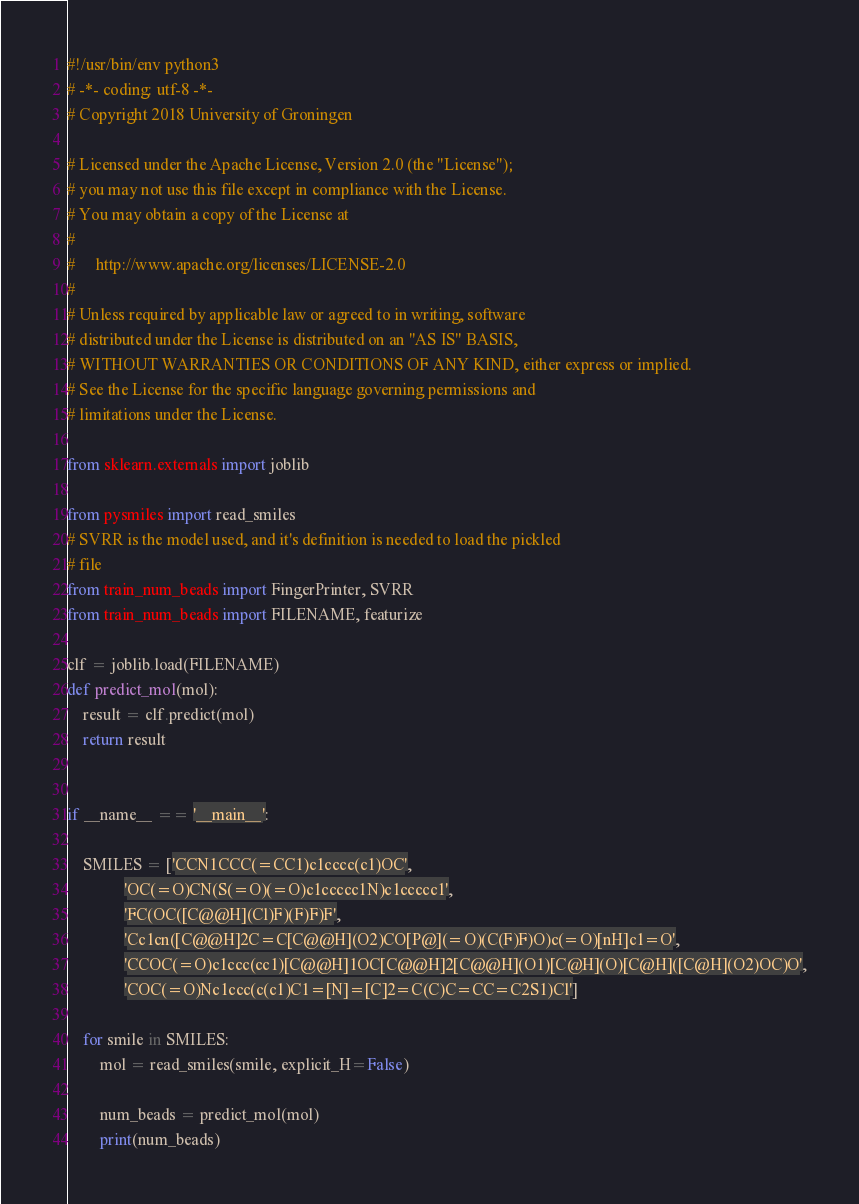Convert code to text. <code><loc_0><loc_0><loc_500><loc_500><_Python_>#!/usr/bin/env python3
# -*- coding: utf-8 -*-
# Copyright 2018 University of Groningen

# Licensed under the Apache License, Version 2.0 (the "License");
# you may not use this file except in compliance with the License.
# You may obtain a copy of the License at
#
#     http://www.apache.org/licenses/LICENSE-2.0
#
# Unless required by applicable law or agreed to in writing, software
# distributed under the License is distributed on an "AS IS" BASIS,
# WITHOUT WARRANTIES OR CONDITIONS OF ANY KIND, either express or implied.
# See the License for the specific language governing permissions and
# limitations under the License.

from sklearn.externals import joblib

from pysmiles import read_smiles
# SVRR is the model used, and it's definition is needed to load the pickled
# file
from train_num_beads import FingerPrinter, SVRR
from train_num_beads import FILENAME, featurize

clf = joblib.load(FILENAME)
def predict_mol(mol):
    result = clf.predict(mol)
    return result


if __name__ == '__main__':

    SMILES = ['CCN1CCC(=CC1)c1cccc(c1)OC',
              'OC(=O)CN(S(=O)(=O)c1ccccc1N)c1ccccc1',
              'FC(OC([C@@H](Cl)F)(F)F)F',
              'Cc1cn([C@@H]2C=C[C@@H](O2)CO[P@](=O)(C(F)F)O)c(=O)[nH]c1=O',
              'CCOC(=O)c1ccc(cc1)[C@@H]1OC[C@@H]2[C@@H](O1)[C@H](O)[C@H]([C@H](O2)OC)O',
              'COC(=O)Nc1ccc(c(c1)C1=[N]=[C]2=C(C)C=CC=C2S1)Cl']

    for smile in SMILES:
        mol = read_smiles(smile, explicit_H=False)

        num_beads = predict_mol(mol)
        print(num_beads)
</code> 